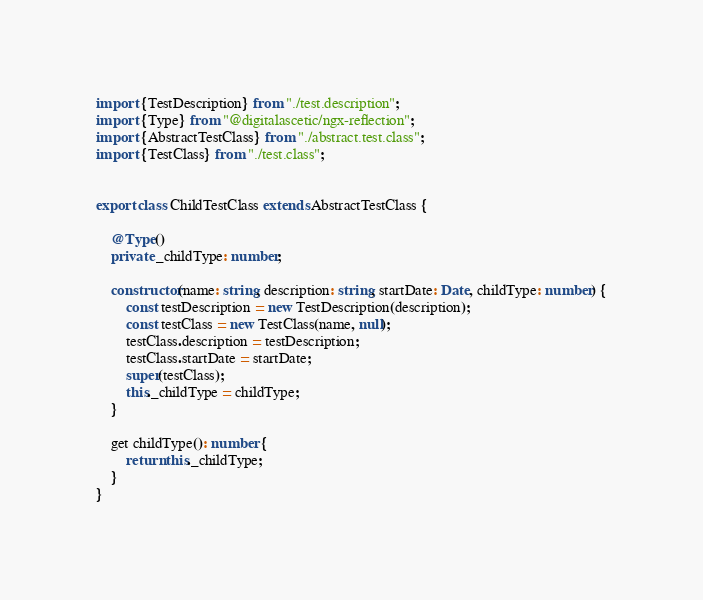<code> <loc_0><loc_0><loc_500><loc_500><_TypeScript_>import {TestDescription} from "./test.description";
import {Type} from "@digitalascetic/ngx-reflection";
import {AbstractTestClass} from "./abstract.test.class";
import {TestClass} from "./test.class";


export class ChildTestClass extends AbstractTestClass {

    @Type()
    private _childType: number;

    constructor(name: string, description: string, startDate: Date, childType: number) {
        const testDescription = new TestDescription(description);
        const testClass = new TestClass(name, null);
        testClass.description = testDescription;
        testClass.startDate = startDate;
        super(testClass);
        this._childType = childType;
    }

    get childType(): number {
        return this._childType;
    }
}
</code> 